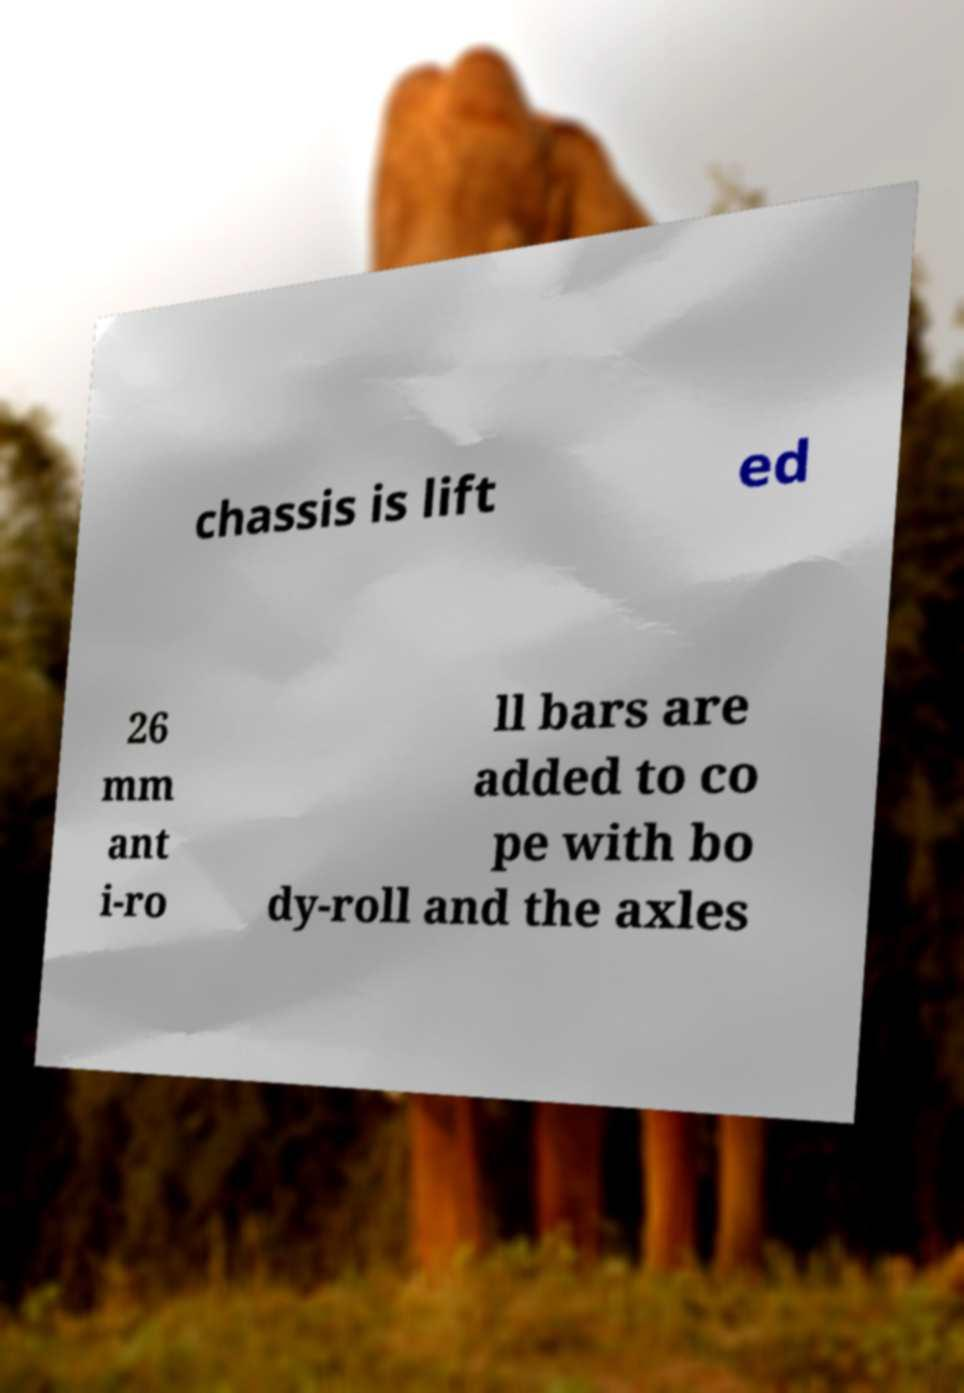Please read and relay the text visible in this image. What does it say? chassis is lift ed 26 mm ant i-ro ll bars are added to co pe with bo dy-roll and the axles 